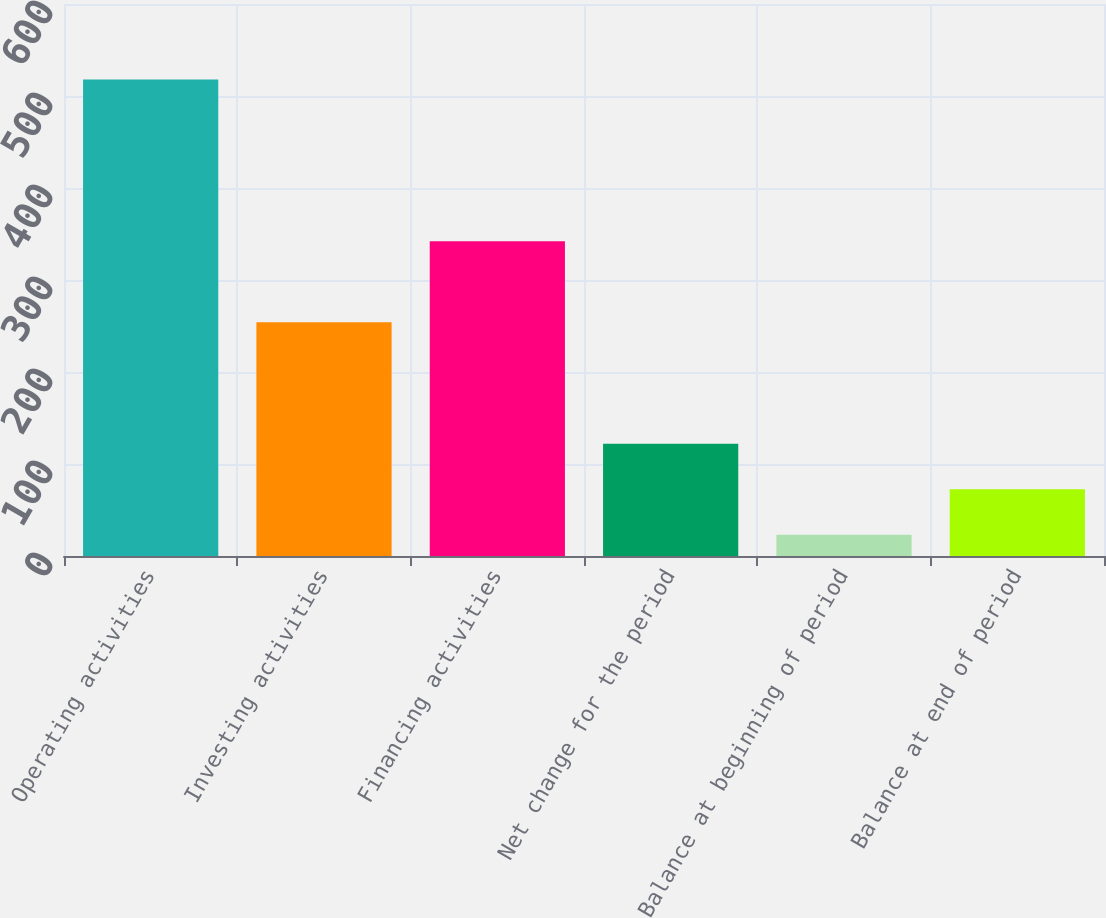Convert chart to OTSL. <chart><loc_0><loc_0><loc_500><loc_500><bar_chart><fcel>Operating activities<fcel>Investing activities<fcel>Financing activities<fcel>Net change for the period<fcel>Balance at beginning of period<fcel>Balance at end of period<nl><fcel>518<fcel>254<fcel>342<fcel>122<fcel>23<fcel>72.5<nl></chart> 